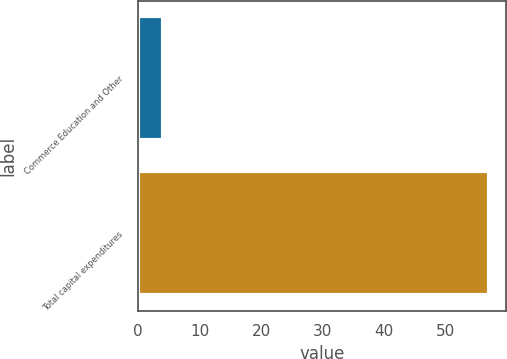Convert chart. <chart><loc_0><loc_0><loc_500><loc_500><bar_chart><fcel>Commerce Education and Other<fcel>Total capital expenditures<nl><fcel>4<fcel>57<nl></chart> 